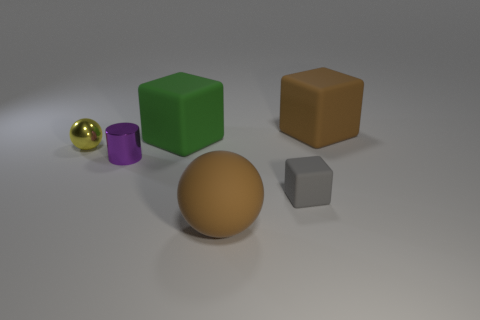Does the tiny object that is on the right side of the green block have the same material as the tiny purple thing?
Your answer should be very brief. No. How many other things are there of the same size as the metal cylinder?
Keep it short and to the point. 2. What number of large things are yellow objects or cubes?
Give a very brief answer. 2. Is the number of brown things that are on the right side of the big matte sphere greater than the number of gray cubes left of the yellow metallic object?
Provide a succinct answer. Yes. There is a matte object in front of the small gray cube; does it have the same color as the metallic sphere?
Give a very brief answer. No. Is there anything else of the same color as the big sphere?
Provide a succinct answer. Yes. Are there more brown objects that are in front of the tiny purple metal cylinder than large cylinders?
Your answer should be very brief. Yes. Is the size of the cylinder the same as the yellow ball?
Your answer should be compact. Yes. There is a large brown object that is the same shape as the small gray thing; what is it made of?
Provide a succinct answer. Rubber. Is there anything else that is the same material as the yellow ball?
Your answer should be very brief. Yes. 